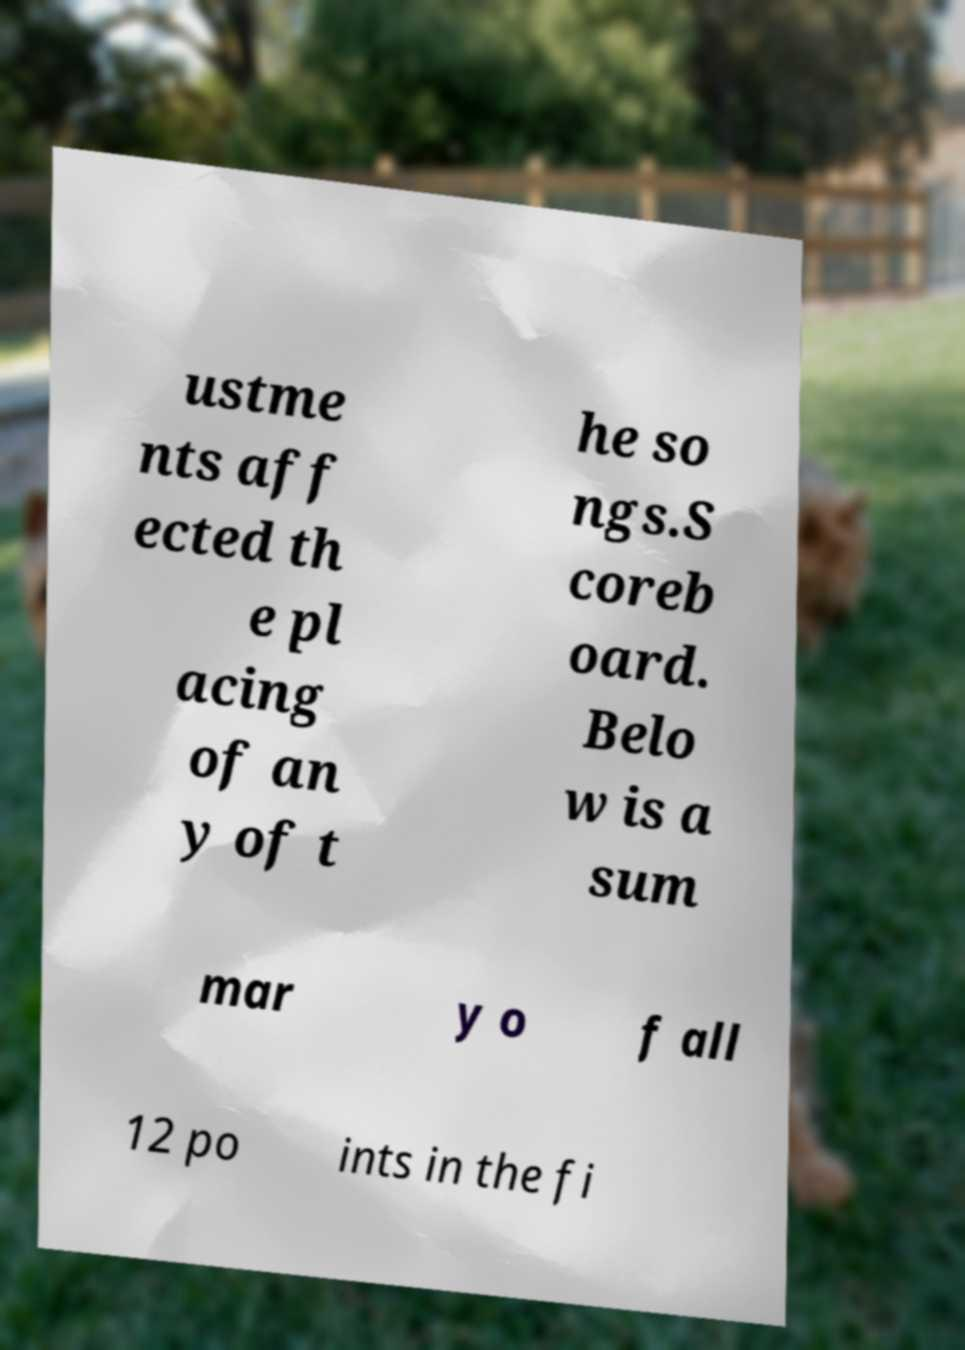Could you extract and type out the text from this image? ustme nts aff ected th e pl acing of an y of t he so ngs.S coreb oard. Belo w is a sum mar y o f all 12 po ints in the fi 